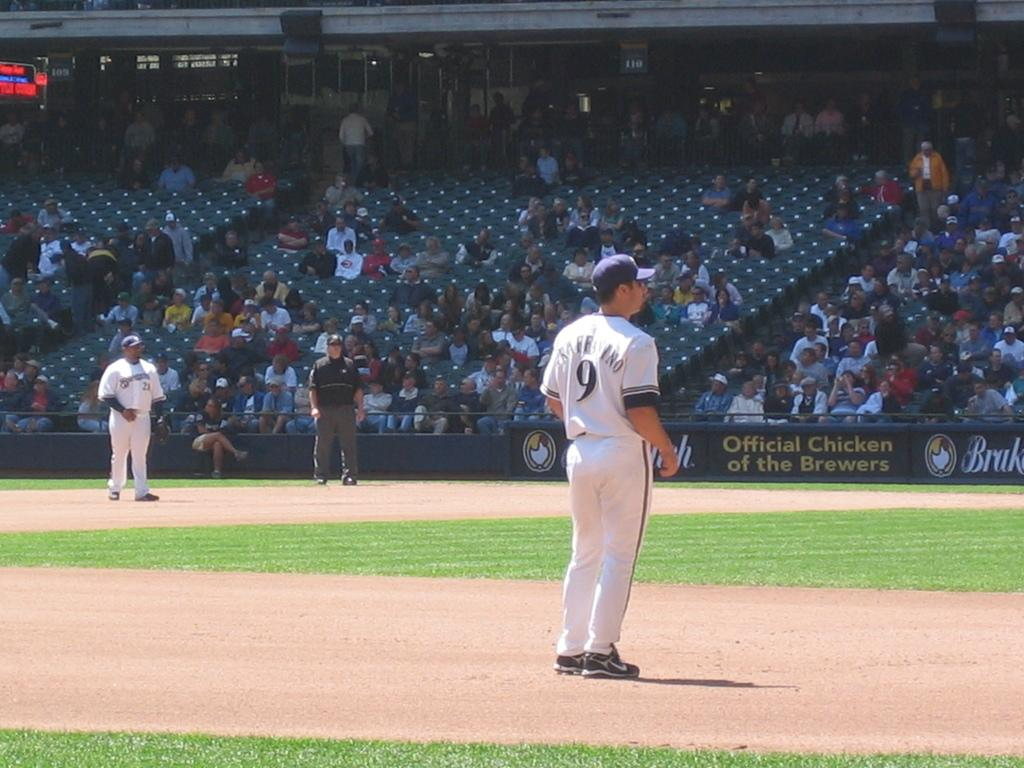<image>
Present a compact description of the photo's key features. A logo for the Official Chicken of the Brewers can be seen on the stadium 